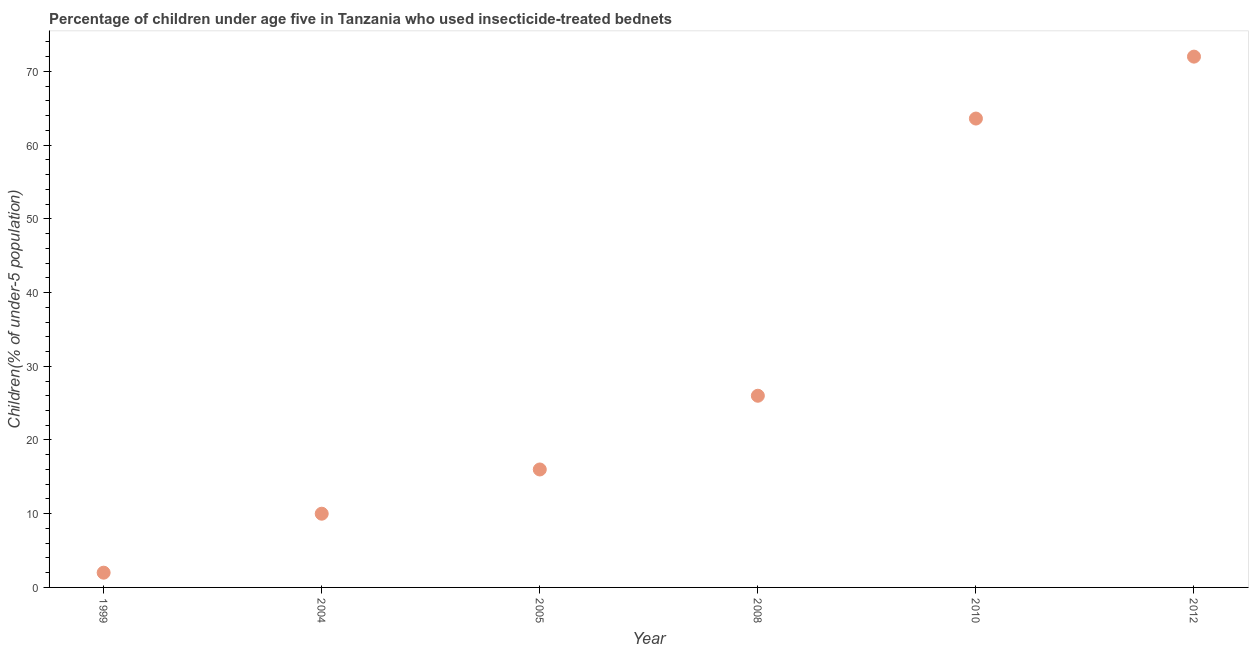What is the percentage of children who use of insecticide-treated bed nets in 2012?
Offer a terse response. 72. Across all years, what is the minimum percentage of children who use of insecticide-treated bed nets?
Your response must be concise. 2. In which year was the percentage of children who use of insecticide-treated bed nets maximum?
Your answer should be very brief. 2012. What is the sum of the percentage of children who use of insecticide-treated bed nets?
Your answer should be very brief. 189.6. What is the difference between the percentage of children who use of insecticide-treated bed nets in 2005 and 2012?
Your answer should be very brief. -56. What is the average percentage of children who use of insecticide-treated bed nets per year?
Provide a short and direct response. 31.6. What is the median percentage of children who use of insecticide-treated bed nets?
Offer a very short reply. 21. In how many years, is the percentage of children who use of insecticide-treated bed nets greater than 10 %?
Give a very brief answer. 4. What is the ratio of the percentage of children who use of insecticide-treated bed nets in 1999 to that in 2008?
Your answer should be compact. 0.08. What is the difference between the highest and the second highest percentage of children who use of insecticide-treated bed nets?
Provide a short and direct response. 8.4. What is the difference between the highest and the lowest percentage of children who use of insecticide-treated bed nets?
Your response must be concise. 70. Are the values on the major ticks of Y-axis written in scientific E-notation?
Offer a very short reply. No. Does the graph contain any zero values?
Provide a succinct answer. No. What is the title of the graph?
Offer a terse response. Percentage of children under age five in Tanzania who used insecticide-treated bednets. What is the label or title of the X-axis?
Provide a short and direct response. Year. What is the label or title of the Y-axis?
Offer a terse response. Children(% of under-5 population). What is the Children(% of under-5 population) in 2008?
Give a very brief answer. 26. What is the Children(% of under-5 population) in 2010?
Offer a terse response. 63.6. What is the Children(% of under-5 population) in 2012?
Your answer should be compact. 72. What is the difference between the Children(% of under-5 population) in 1999 and 2004?
Keep it short and to the point. -8. What is the difference between the Children(% of under-5 population) in 1999 and 2010?
Keep it short and to the point. -61.6. What is the difference between the Children(% of under-5 population) in 1999 and 2012?
Offer a very short reply. -70. What is the difference between the Children(% of under-5 population) in 2004 and 2005?
Your answer should be compact. -6. What is the difference between the Children(% of under-5 population) in 2004 and 2010?
Your answer should be compact. -53.6. What is the difference between the Children(% of under-5 population) in 2004 and 2012?
Ensure brevity in your answer.  -62. What is the difference between the Children(% of under-5 population) in 2005 and 2010?
Provide a succinct answer. -47.6. What is the difference between the Children(% of under-5 population) in 2005 and 2012?
Ensure brevity in your answer.  -56. What is the difference between the Children(% of under-5 population) in 2008 and 2010?
Make the answer very short. -37.6. What is the difference between the Children(% of under-5 population) in 2008 and 2012?
Provide a short and direct response. -46. What is the ratio of the Children(% of under-5 population) in 1999 to that in 2005?
Provide a short and direct response. 0.12. What is the ratio of the Children(% of under-5 population) in 1999 to that in 2008?
Your answer should be compact. 0.08. What is the ratio of the Children(% of under-5 population) in 1999 to that in 2010?
Provide a succinct answer. 0.03. What is the ratio of the Children(% of under-5 population) in 1999 to that in 2012?
Ensure brevity in your answer.  0.03. What is the ratio of the Children(% of under-5 population) in 2004 to that in 2008?
Provide a succinct answer. 0.39. What is the ratio of the Children(% of under-5 population) in 2004 to that in 2010?
Offer a terse response. 0.16. What is the ratio of the Children(% of under-5 population) in 2004 to that in 2012?
Offer a very short reply. 0.14. What is the ratio of the Children(% of under-5 population) in 2005 to that in 2008?
Keep it short and to the point. 0.61. What is the ratio of the Children(% of under-5 population) in 2005 to that in 2010?
Make the answer very short. 0.25. What is the ratio of the Children(% of under-5 population) in 2005 to that in 2012?
Make the answer very short. 0.22. What is the ratio of the Children(% of under-5 population) in 2008 to that in 2010?
Offer a terse response. 0.41. What is the ratio of the Children(% of under-5 population) in 2008 to that in 2012?
Your answer should be compact. 0.36. What is the ratio of the Children(% of under-5 population) in 2010 to that in 2012?
Your answer should be compact. 0.88. 